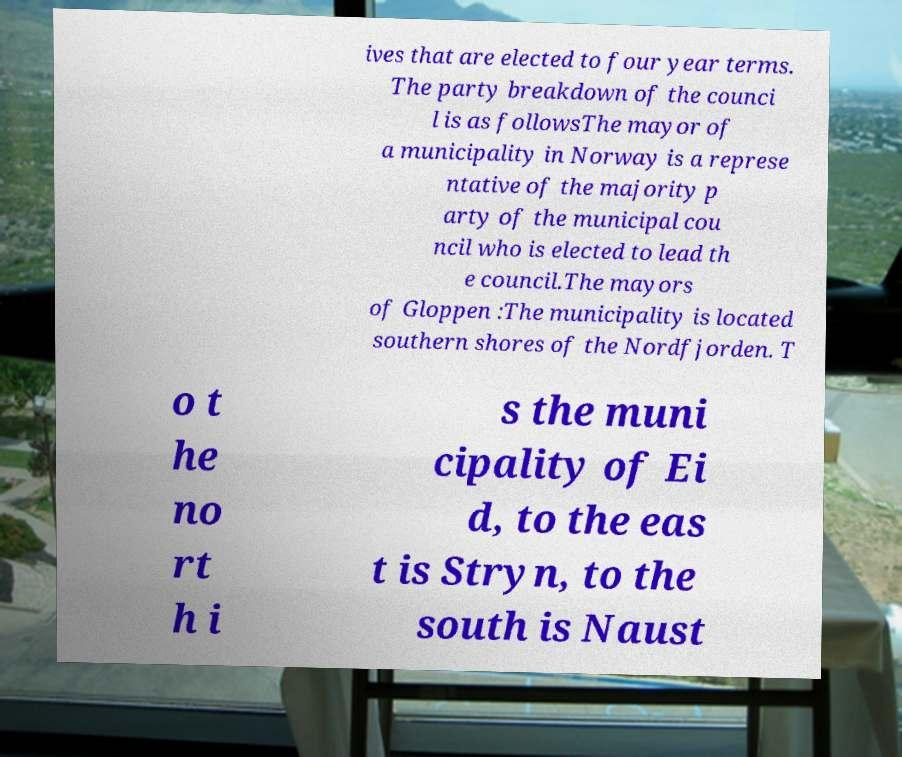Can you accurately transcribe the text from the provided image for me? ives that are elected to four year terms. The party breakdown of the counci l is as followsThe mayor of a municipality in Norway is a represe ntative of the majority p arty of the municipal cou ncil who is elected to lead th e council.The mayors of Gloppen :The municipality is located southern shores of the Nordfjorden. T o t he no rt h i s the muni cipality of Ei d, to the eas t is Stryn, to the south is Naust 